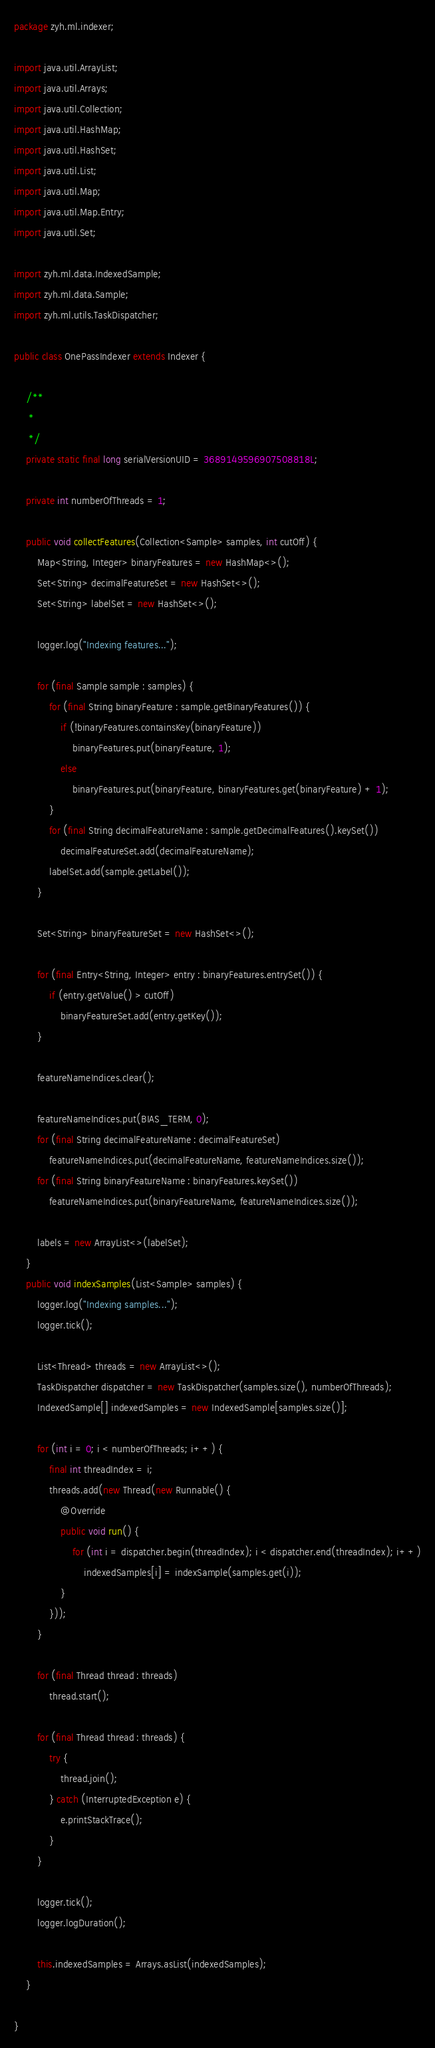Convert code to text. <code><loc_0><loc_0><loc_500><loc_500><_Java_>package zyh.ml.indexer;

import java.util.ArrayList;
import java.util.Arrays;
import java.util.Collection;
import java.util.HashMap;
import java.util.HashSet;
import java.util.List;
import java.util.Map;
import java.util.Map.Entry;
import java.util.Set;

import zyh.ml.data.IndexedSample;
import zyh.ml.data.Sample;
import zyh.ml.utils.TaskDispatcher;

public class OnePassIndexer extends Indexer {

	/**
	 *
	 */
	private static final long serialVersionUID = 3689149596907508818L;

	private int numberOfThreads = 1;

	public void collectFeatures(Collection<Sample> samples, int cutOff) {
		Map<String, Integer> binaryFeatures = new HashMap<>();
		Set<String> decimalFeatureSet = new HashSet<>();
		Set<String> labelSet = new HashSet<>();

		logger.log("Indexing features...");

		for (final Sample sample : samples) {
			for (final String binaryFeature : sample.getBinaryFeatures()) {
				if (!binaryFeatures.containsKey(binaryFeature))
					binaryFeatures.put(binaryFeature, 1);
				else
					binaryFeatures.put(binaryFeature, binaryFeatures.get(binaryFeature) + 1);
			}
			for (final String decimalFeatureName : sample.getDecimalFeatures().keySet())
				decimalFeatureSet.add(decimalFeatureName);
			labelSet.add(sample.getLabel());
		}

		Set<String> binaryFeatureSet = new HashSet<>();

		for (final Entry<String, Integer> entry : binaryFeatures.entrySet()) {
			if (entry.getValue() > cutOff)
				binaryFeatureSet.add(entry.getKey());
		}

		featureNameIndices.clear();

		featureNameIndices.put(BIAS_TERM, 0);
		for (final String decimalFeatureName : decimalFeatureSet)
			featureNameIndices.put(decimalFeatureName, featureNameIndices.size());
		for (final String binaryFeatureName : binaryFeatures.keySet())
			featureNameIndices.put(binaryFeatureName, featureNameIndices.size());

		labels = new ArrayList<>(labelSet);
	}
	public void indexSamples(List<Sample> samples) {
		logger.log("Indexing samples...");
		logger.tick();

		List<Thread> threads = new ArrayList<>();
		TaskDispatcher dispatcher = new TaskDispatcher(samples.size(), numberOfThreads);
		IndexedSample[] indexedSamples = new IndexedSample[samples.size()];

		for (int i = 0; i < numberOfThreads; i++) {
			final int threadIndex = i;
			threads.add(new Thread(new Runnable() {
				@Override
				public void run() {
					for (int i = dispatcher.begin(threadIndex); i < dispatcher.end(threadIndex); i++)
						indexedSamples[i] = indexSample(samples.get(i));
				}
			}));
		}

		for (final Thread thread : threads)
			thread.start();

		for (final Thread thread : threads) {
			try {
				thread.join();
			} catch (InterruptedException e) {
				e.printStackTrace();
			}
		}

		logger.tick();
		logger.logDuration();

		this.indexedSamples = Arrays.asList(indexedSamples);
	}

}
</code> 